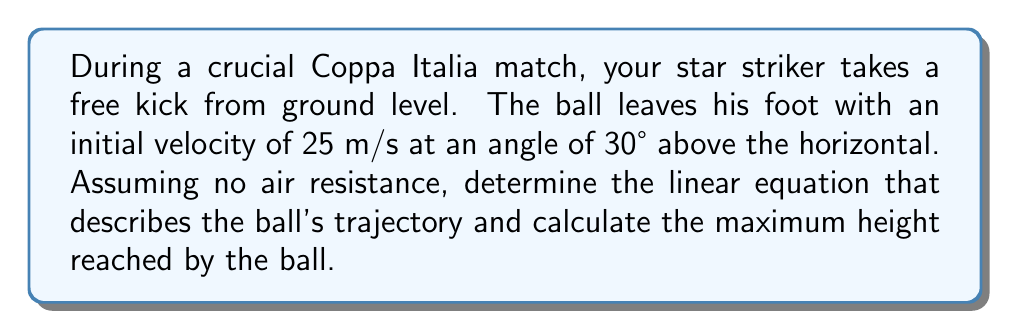Can you answer this question? Let's approach this step-by-step:

1) In projectile motion, the trajectory of an object follows a parabolic path, which can be described by a quadratic equation. We'll derive this equation using the initial conditions.

2) Let's define our coordinate system:
   - x-axis: horizontal distance
   - y-axis: vertical distance (height)
   - Origin (0,0): point where the ball is kicked

3) We need to break down the initial velocity into its x and y components:
   $v_x = v \cos \theta = 25 \cos 30° = 21.65$ m/s
   $v_y = v \sin \theta = 25 \sin 30° = 12.5$ m/s

4) The equations of motion for x and y are:
   $x = v_x t$
   $y = v_y t - \frac{1}{2}gt^2$

   where g is the acceleration due to gravity (9.8 m/s²)

5) To get y in terms of x, we need to eliminate t:
   $t = \frac{x}{v_x}$

6) Substituting this into the equation for y:
   $y = v_y (\frac{x}{v_x}) - \frac{1}{2}g(\frac{x}{v_x})^2$

7) Simplifying:
   $y = (\frac{v_y}{v_x})x - (\frac{g}{2v_x^2})x^2$

8) Substituting the values:
   $y = (\frac{12.5}{21.65})x - (\frac{9.8}{2(21.65)^2})x^2$
   $y = 0.577x - 0.0104x^2$

This is the linear equation describing the ball's trajectory.

9) To find the maximum height, we need to find the vertex of this parabola. The x-coordinate of the vertex is given by:
   $x_{vertex} = -\frac{b}{2a} = -\frac{0.577}{2(-0.0104)} = 27.74$ m

10) The maximum height (y-coordinate of the vertex) is:
    $y_{max} = 0.577(27.74) - 0.0104(27.74)^2 = 8.01$ m
Answer: Trajectory equation: $y = 0.577x - 0.0104x^2$; Maximum height: 8.01 m 